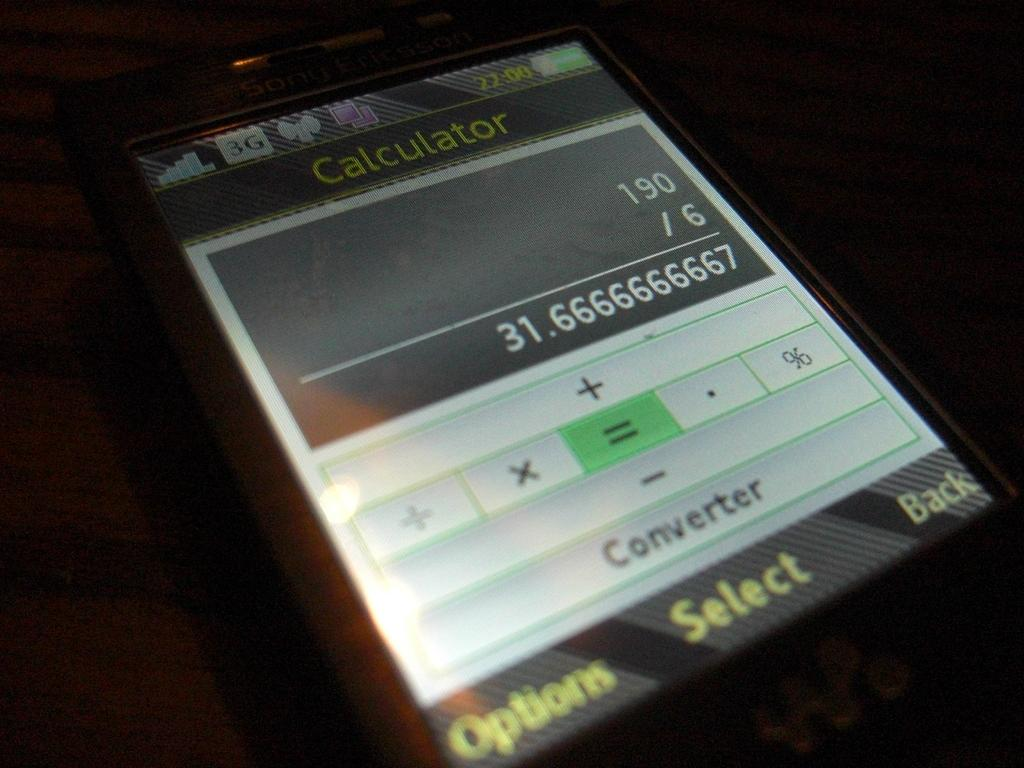<image>
Share a concise interpretation of the image provided. a calculator with 31.6 on it that also has an equal sign 